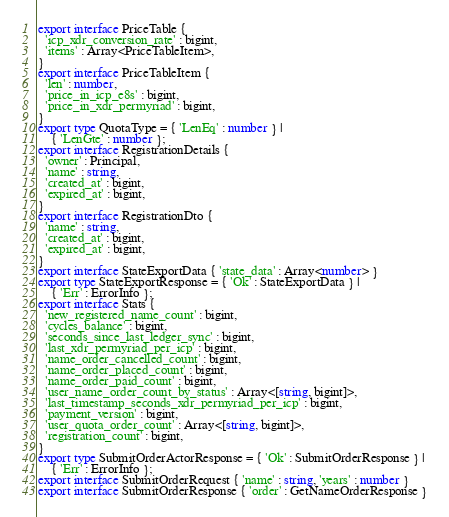Convert code to text. <code><loc_0><loc_0><loc_500><loc_500><_TypeScript_>export interface PriceTable {
  'icp_xdr_conversion_rate' : bigint,
  'items' : Array<PriceTableItem>,
}
export interface PriceTableItem {
  'len' : number,
  'price_in_icp_e8s' : bigint,
  'price_in_xdr_permyriad' : bigint,
}
export type QuotaType = { 'LenEq' : number } |
    { 'LenGte' : number };
export interface RegistrationDetails {
  'owner' : Principal,
  'name' : string,
  'created_at' : bigint,
  'expired_at' : bigint,
}
export interface RegistrationDto {
  'name' : string,
  'created_at' : bigint,
  'expired_at' : bigint,
}
export interface StateExportData { 'state_data' : Array<number> }
export type StateExportResponse = { 'Ok' : StateExportData } |
    { 'Err' : ErrorInfo };
export interface Stats {
  'new_registered_name_count' : bigint,
  'cycles_balance' : bigint,
  'seconds_since_last_ledger_sync' : bigint,
  'last_xdr_permyriad_per_icp' : bigint,
  'name_order_cancelled_count' : bigint,
  'name_order_placed_count' : bigint,
  'name_order_paid_count' : bigint,
  'user_name_order_count_by_status' : Array<[string, bigint]>,
  'last_timestamp_seconds_xdr_permyriad_per_icp' : bigint,
  'payment_version' : bigint,
  'user_quota_order_count' : Array<[string, bigint]>,
  'registration_count' : bigint,
}
export type SubmitOrderActorResponse = { 'Ok' : SubmitOrderResponse } |
    { 'Err' : ErrorInfo };
export interface SubmitOrderRequest { 'name' : string, 'years' : number }
export interface SubmitOrderResponse { 'order' : GetNameOrderResponse }</code> 